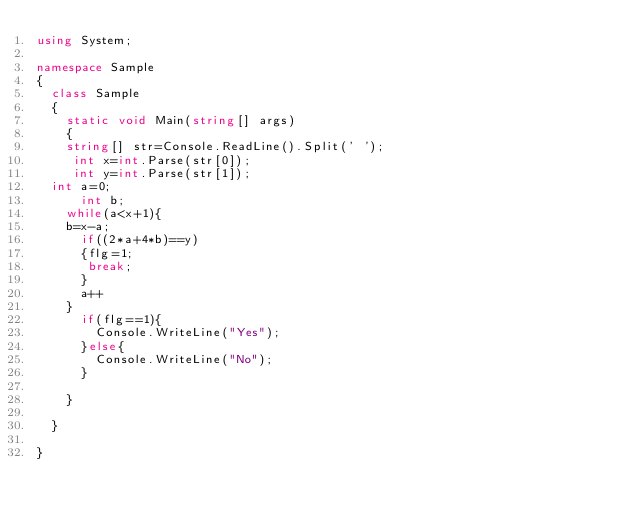Convert code to text. <code><loc_0><loc_0><loc_500><loc_500><_C#_>using System;
 
namespace Sample
{
  class Sample
  {
    static void Main(string[] args)
    {
    string[] str=Console.ReadLine().Split(' ');
     int x=int.Parse(str[0]);
     int y=int.Parse(str[1]);
	int a=0;
      int b;
    while(a<x+1){
    b=x-a;
      if((2*a+4*b)==y)
      {flg=1;
       break;
      }
      a++
    }
      if(flg==1){
        Console.WriteLine("Yes");
      }else{
        Console.WriteLine("No");
      }
     
    }
    
  }

}
</code> 